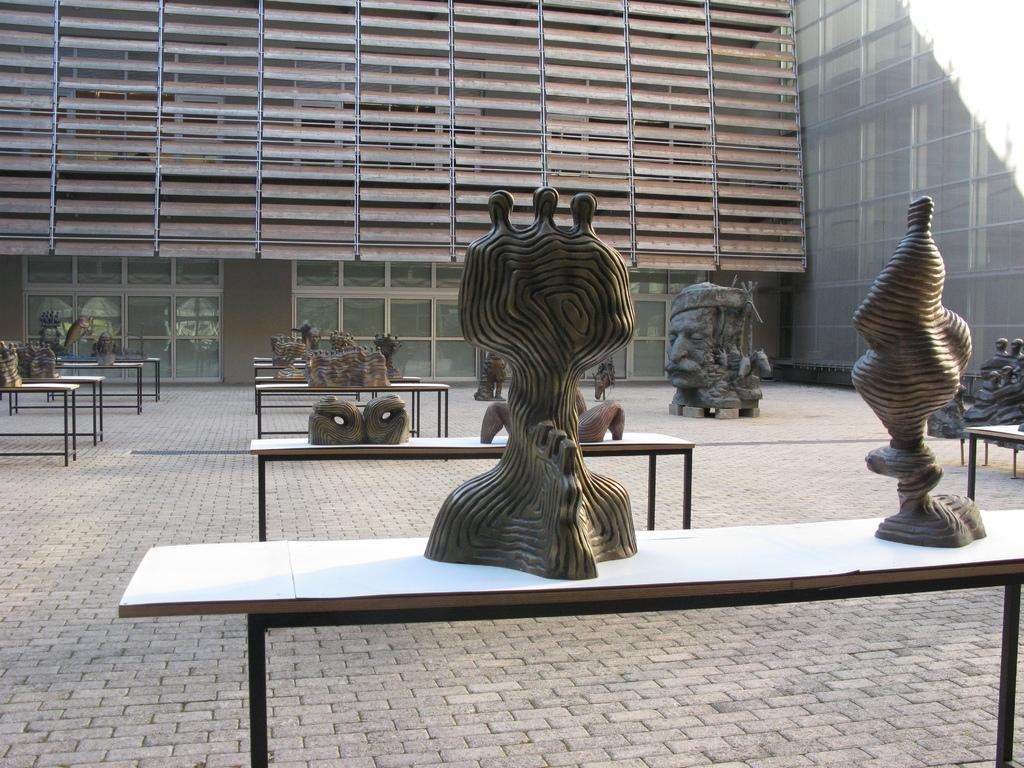What objects are on the table in the image? There are sculptures on the table in the image. What architectural features can be seen in the background of the image? There are doors and windows in the background of the image. What type of skate is being used by the tiger in the image? There is no skate or tiger present in the image. 